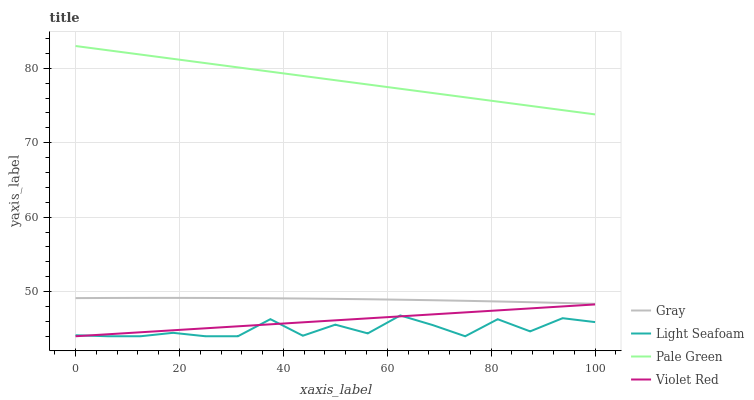Does Light Seafoam have the minimum area under the curve?
Answer yes or no. Yes. Does Pale Green have the maximum area under the curve?
Answer yes or no. Yes. Does Pale Green have the minimum area under the curve?
Answer yes or no. No. Does Light Seafoam have the maximum area under the curve?
Answer yes or no. No. Is Violet Red the smoothest?
Answer yes or no. Yes. Is Light Seafoam the roughest?
Answer yes or no. Yes. Is Pale Green the smoothest?
Answer yes or no. No. Is Pale Green the roughest?
Answer yes or no. No. Does Light Seafoam have the lowest value?
Answer yes or no. Yes. Does Pale Green have the lowest value?
Answer yes or no. No. Does Pale Green have the highest value?
Answer yes or no. Yes. Does Light Seafoam have the highest value?
Answer yes or no. No. Is Gray less than Pale Green?
Answer yes or no. Yes. Is Pale Green greater than Light Seafoam?
Answer yes or no. Yes. Does Violet Red intersect Light Seafoam?
Answer yes or no. Yes. Is Violet Red less than Light Seafoam?
Answer yes or no. No. Is Violet Red greater than Light Seafoam?
Answer yes or no. No. Does Gray intersect Pale Green?
Answer yes or no. No. 